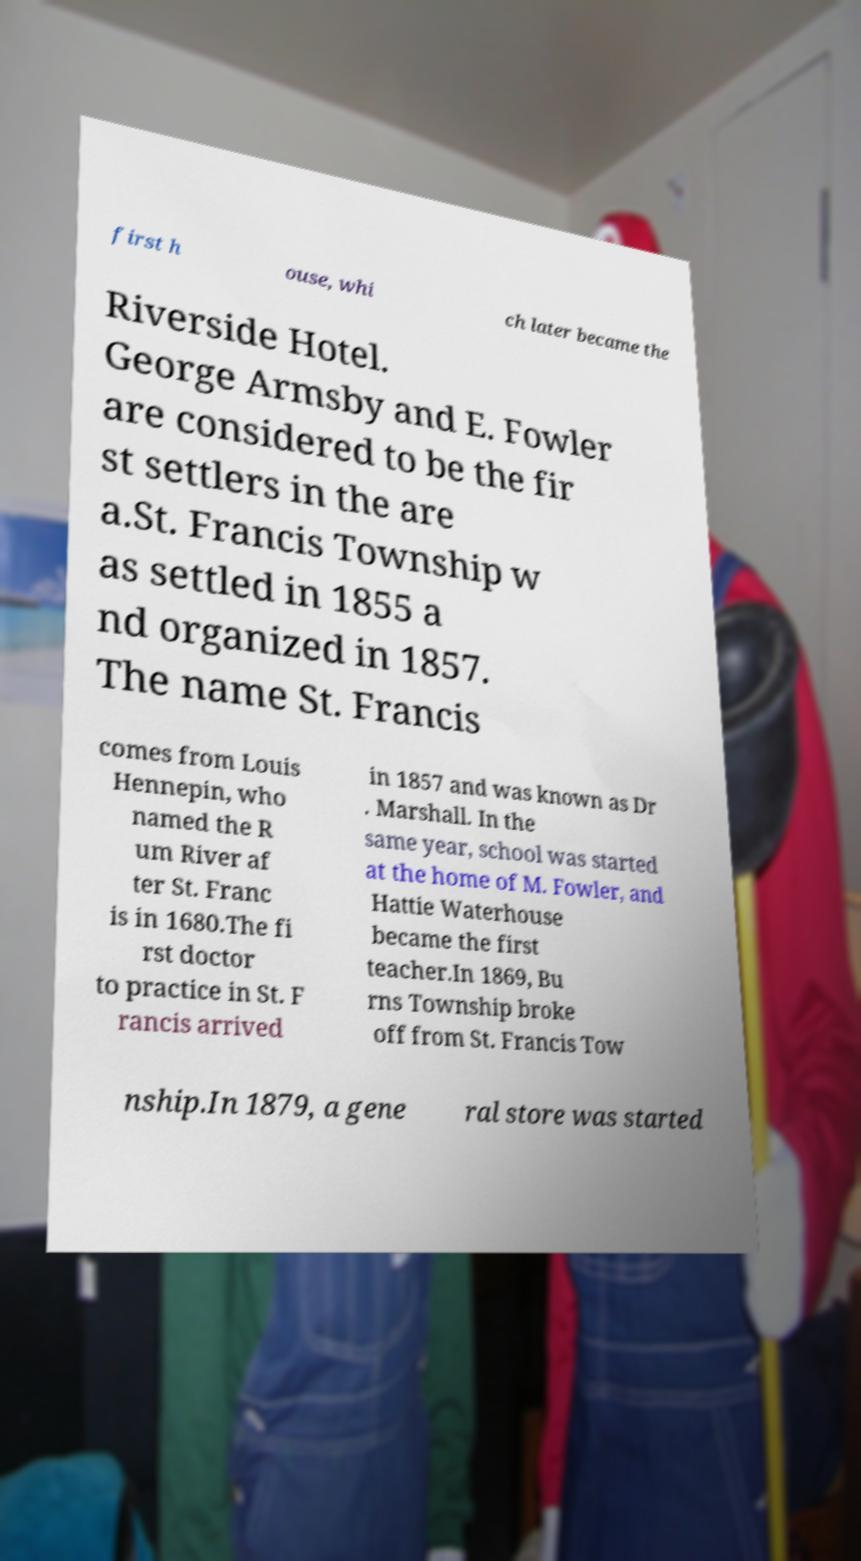I need the written content from this picture converted into text. Can you do that? first h ouse, whi ch later became the Riverside Hotel. George Armsby and E. Fowler are considered to be the fir st settlers in the are a.St. Francis Township w as settled in 1855 a nd organized in 1857. The name St. Francis comes from Louis Hennepin, who named the R um River af ter St. Franc is in 1680.The fi rst doctor to practice in St. F rancis arrived in 1857 and was known as Dr . Marshall. In the same year, school was started at the home of M. Fowler, and Hattie Waterhouse became the first teacher.In 1869, Bu rns Township broke off from St. Francis Tow nship.In 1879, a gene ral store was started 